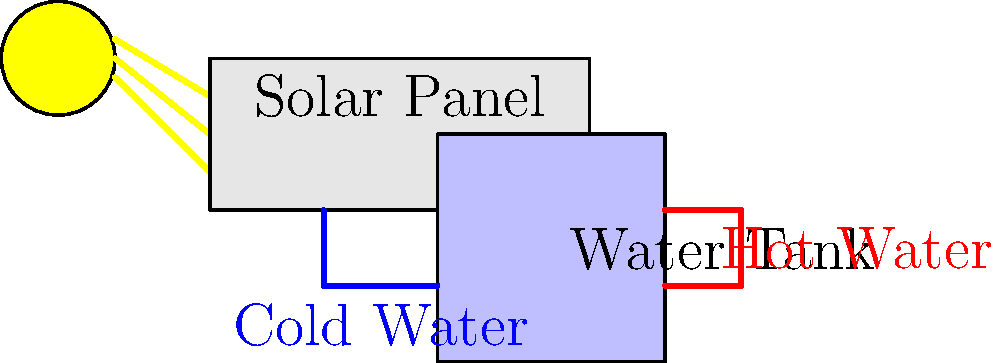In our village, we've started using a simple solar water heater. How does the heat from the sun warm the water in the tank? Explain the main heat transfer principle involved in this process. To understand how the solar water heater works, let's break it down step-by-step:

1. Solar radiation: The sun emits energy in the form of electromagnetic radiation.

2. Absorption: The solar panel (collector) is designed to absorb this solar radiation. It's usually dark-colored to maximize absorption.

3. Conversion to heat: The absorbed solar energy is converted into heat energy within the solar panel.

4. Conduction: The heat is then transferred to the water pipes in contact with the solar panel through conduction. Conduction is the transfer of heat through direct contact between particles of matter.

5. Convection in pipes: As the water in the pipes heats up, it becomes less dense and rises. This creates a natural circulation known as thermosiphon effect.

6. Heat transfer to tank: The hot water flows into the storage tank, transferring its heat to the cooler water in the tank.

7. Continuous cycle: Cooler water from the bottom of the tank flows back into the solar panel, continuing the cycle.

The main heat transfer principle involved in this process is convection. Convection is the transfer of heat by the movement of fluids (in this case, water). The natural circulation of water due to density differences (thermosiphon effect) is what primarily moves the heated water from the solar panel to the storage tank, effectively transferring heat throughout the system.
Answer: Convection (thermosiphon effect) 